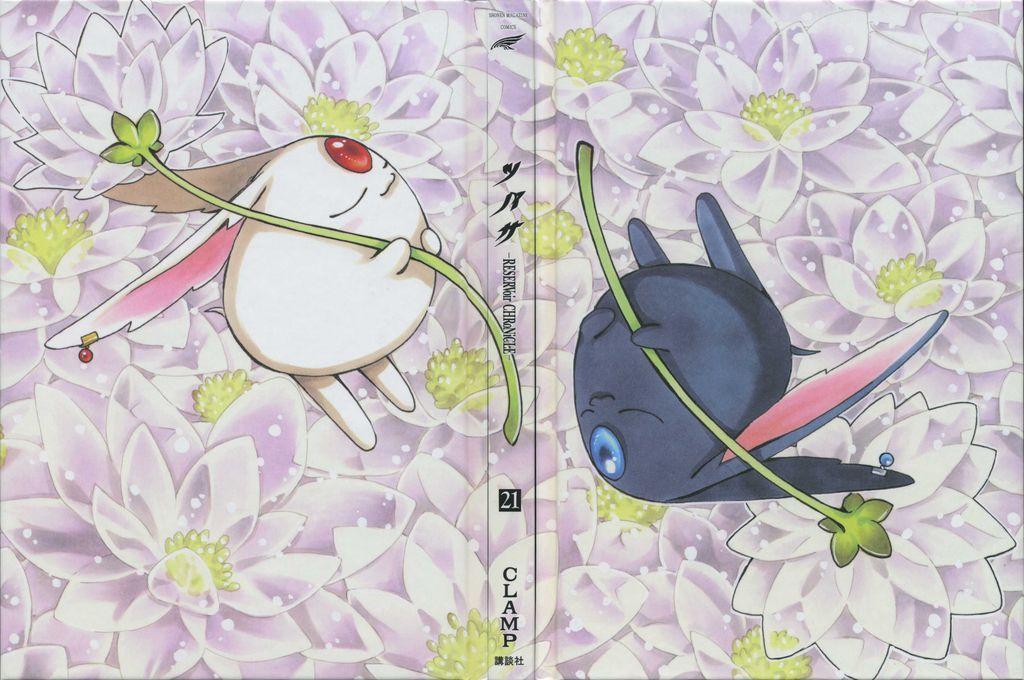How would you summarize this image in a sentence or two? In this image I can see the animated picture in which I can see two objects which are white and black in color holding green colored plants in their hands. I can see few flowers which are white, purple and green in color. 